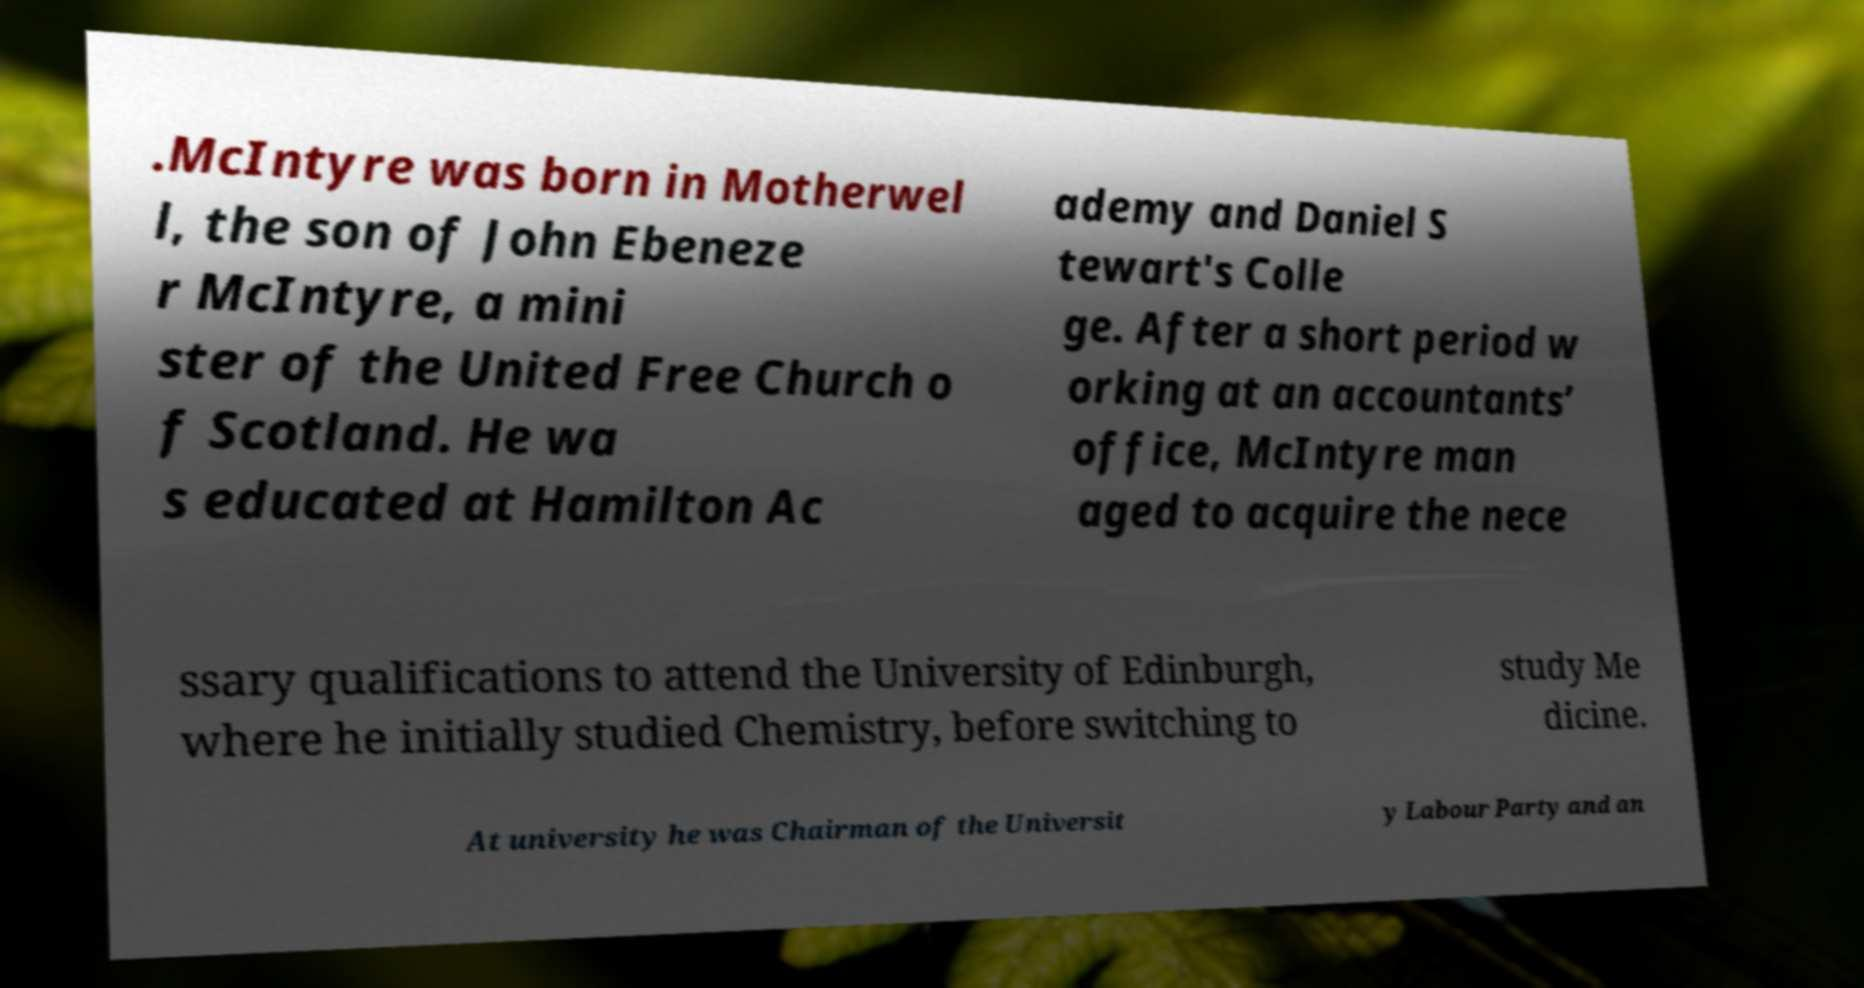Can you read and provide the text displayed in the image?This photo seems to have some interesting text. Can you extract and type it out for me? .McIntyre was born in Motherwel l, the son of John Ebeneze r McIntyre, a mini ster of the United Free Church o f Scotland. He wa s educated at Hamilton Ac ademy and Daniel S tewart's Colle ge. After a short period w orking at an accountants’ office, McIntyre man aged to acquire the nece ssary qualifications to attend the University of Edinburgh, where he initially studied Chemistry, before switching to study Me dicine. At university he was Chairman of the Universit y Labour Party and an 